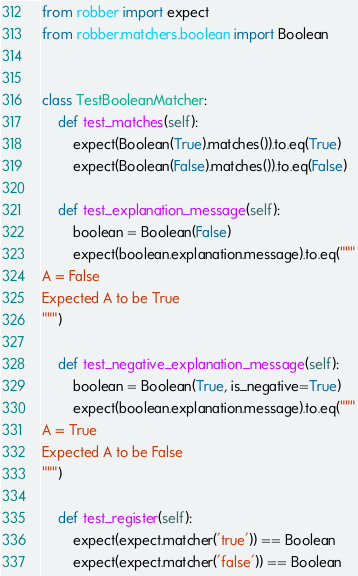Convert code to text. <code><loc_0><loc_0><loc_500><loc_500><_Python_>from robber import expect
from robber.matchers.boolean import Boolean


class TestBooleanMatcher:
    def test_matches(self):
        expect(Boolean(True).matches()).to.eq(True)
        expect(Boolean(False).matches()).to.eq(False)

    def test_explanation_message(self):
        boolean = Boolean(False)
        expect(boolean.explanation.message).to.eq("""
A = False
Expected A to be True
""")

    def test_negative_explanation_message(self):
        boolean = Boolean(True, is_negative=True)
        expect(boolean.explanation.message).to.eq("""
A = True
Expected A to be False
""")

    def test_register(self):
        expect(expect.matcher('true')) == Boolean
        expect(expect.matcher('false')) == Boolean
</code> 